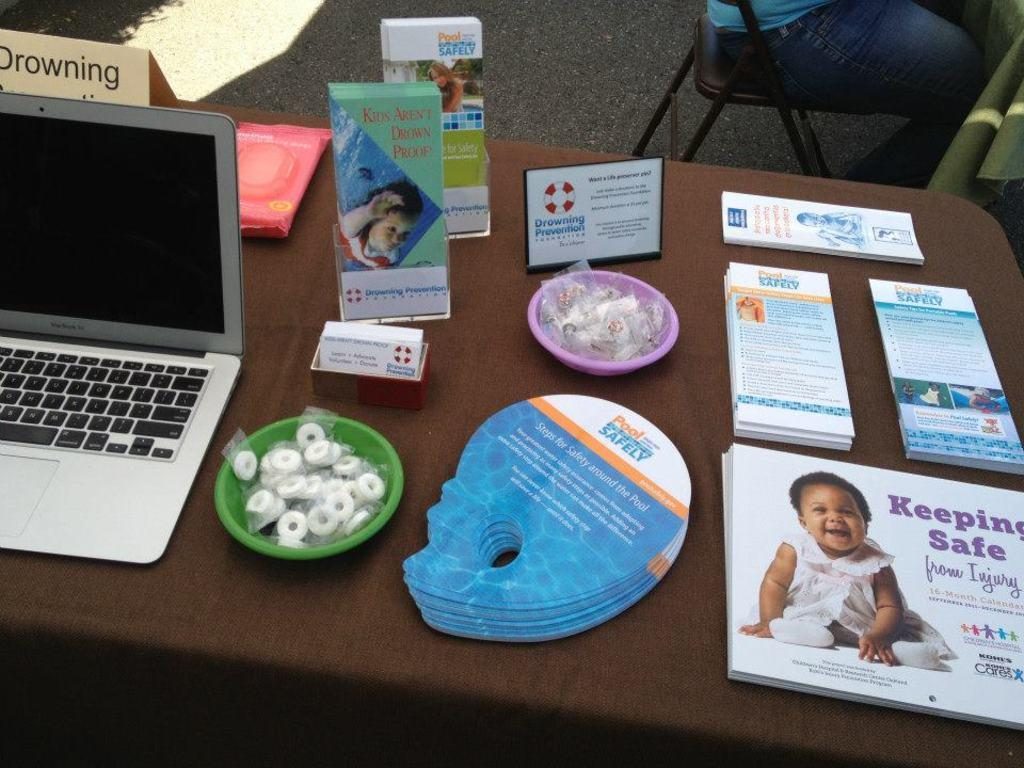<image>
Describe the image concisely. A series of products on a table about keeping safe in pools. 